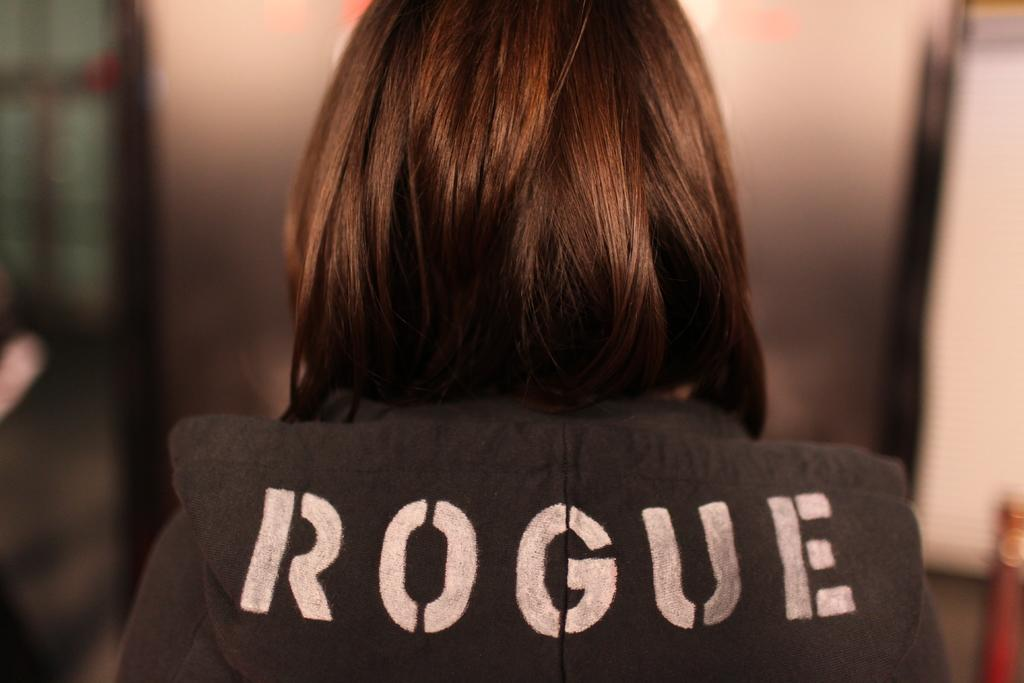What is the main subject of the image? There is a person in the image. What object is located beside the person? There is a pole beside the person. Can you describe the background of the image? The background of the image is blurred. How many deer can be seen grazing in the background of the image? There are no deer present in the image; the background is blurred. 